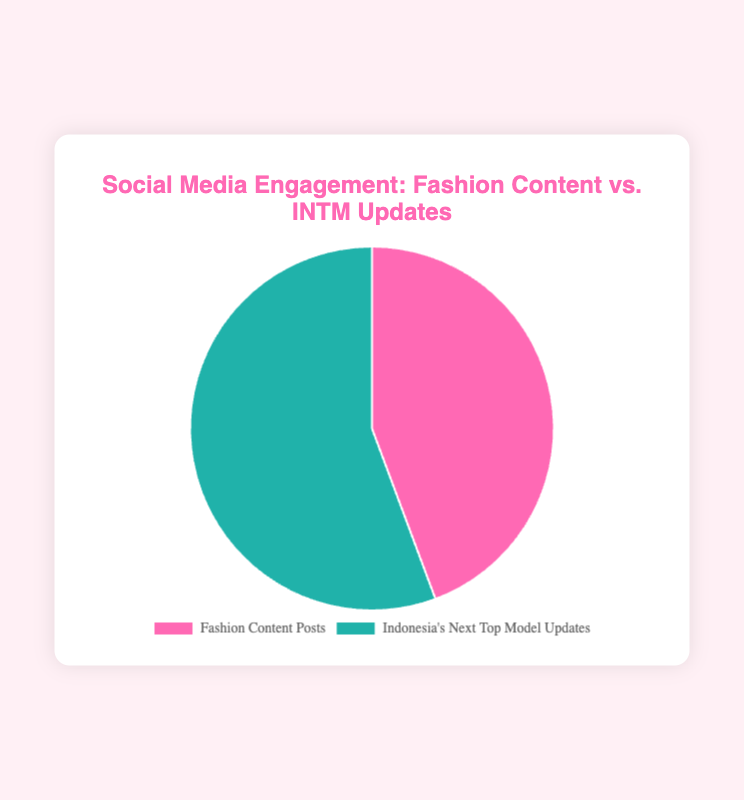Which type of content has higher social media engagement? The data points are shown with two categories: "Fashion Content Posts" and "Indonesia's Next Top Model Updates." By observing the pie chart, we can see that the segment for "Indonesia's Next Top Model Updates" is larger. This indicates higher engagement.
Answer: Indonesia's Next Top Model Updates What is the total social media engagement for Fashion Content Posts? The pie chart data for Fashion Content Posts sums up to 125,000 engagements, including Instagram Likes, Instagram Comments, Facebook Reactions, Facebook Comments, Twitter Retweets, and Twitter Likes.
Answer: 125,000 Which content type has a larger proportion in the pie chart and by what color is it represented? Indonesia's Next Top Model Updates has the larger segment in the pie chart and is represented in a greenish color. Fashion Content Posts are in a pinkish color.
Answer: Greenish color (Indonesia's Next Top Model Updates) What is the difference in total engagements between Fashion Content Posts and Indonesia's Next Top Model Updates? Indonesia's Next Top Model Updates have 157,000 engagements, while Fashion Content Posts have 125,000 engagements. The difference is 157,000 - 125,000.
Answer: 32,000 How much engagement does Indonesia's Next Top Model Updates receive compared to Fashion Content Posts in terms of percentage? To find the percentage, divide the total engagements of Indonesia's Next Top Model Updates by the total engagements of Fashion Content Posts, then multiply by 100. (157,000 / 125,000) * 100.
Answer: 125.6% Which segment (Fashion Content Posts or Indonesia's Next Top Model Updates) appears larger if we only consider Instagram Likes? Indonesia's Next Top Model Updates have 60,000 Instagram Likes, whereas Fashion Content Posts have 50,000 Instagram Likes. The segment for Indonesia's Next Top Model Updates is larger for Instagram Likes.
Answer: Indonesia's Next Top Model Updates Based on the pie chart, which segment is visually larger, and does it account for more than 50% of the total engagements? Indonesia's Next Top Model Updates is visually larger. However, it does not account for more than 50% because 157,000 is less than double the 125,000 of Fashion Content Posts.
Answer: No If you add up all the engagements from Instagram, Facebook, and Twitter for Fashion Content Posts, what would the total be? Summing up all engagements from Instagram Likes (50,000), Instagram Comments (15,000), Facebook Reactions (20,000), Facebook Comments (5,000), Twitter Retweets (10,000), and Twitter Likes (25,000): 50,000 + 15,000 + 20,000 + 5,000 + 10,000 + 25,000 = 125,000.
Answer: 125,000 Which category has more Twitter engagements? Indonesia's Next Top Model Updates receive 15,000 Twitter Retweets and 30,000 Twitter Likes, totaling 45,000. Fashion Content Posts receive 10,000 Twitter Retweets and 25,000 Twitter Likes, totaling 35,000. Indonesia's Next Top Model Updates have more Twitter engagements.
Answer: Indonesia's Next Top Model Updates 